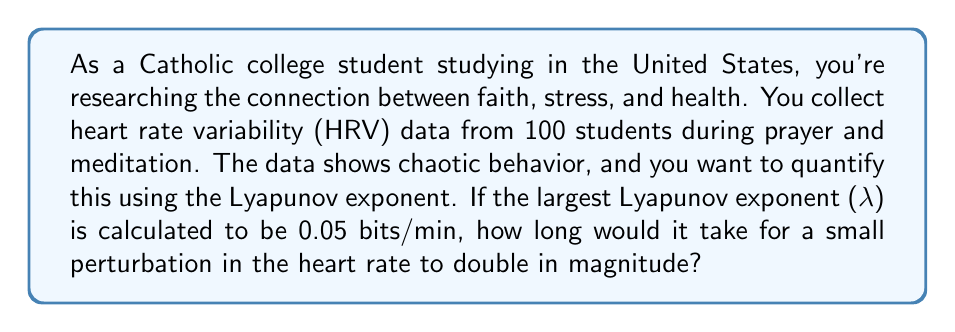Can you answer this question? To solve this problem, we need to understand the relationship between the Lyapunov exponent and the doubling time of a perturbation in a chaotic system. The Lyapunov exponent quantifies the rate of divergence of nearby trajectories in phase space.

Step 1: Understand the meaning of the Lyapunov exponent
The Lyapunov exponent (λ) represents the average rate at which nearby trajectories in a dynamical system diverge. A positive Lyapunov exponent indicates chaos.

Step 2: Relate the Lyapunov exponent to the doubling time
The relationship between the Lyapunov exponent and the doubling time (T) is given by:

$$λ = \frac{\ln(2)}{T}$$

Step 3: Rearrange the equation to solve for T
$$T = \frac{\ln(2)}{λ}$$

Step 4: Substitute the given value of λ and calculate
Given: λ = 0.05 bits/min

$$T = \frac{\ln(2)}{0.05} \approx \frac{0.693}{0.05} = 13.86 \text{ minutes}$$

Step 5: Round to the nearest minute
T ≈ 14 minutes

Therefore, it would take approximately 14 minutes for a small perturbation in the heart rate to double in magnitude.
Answer: 14 minutes 